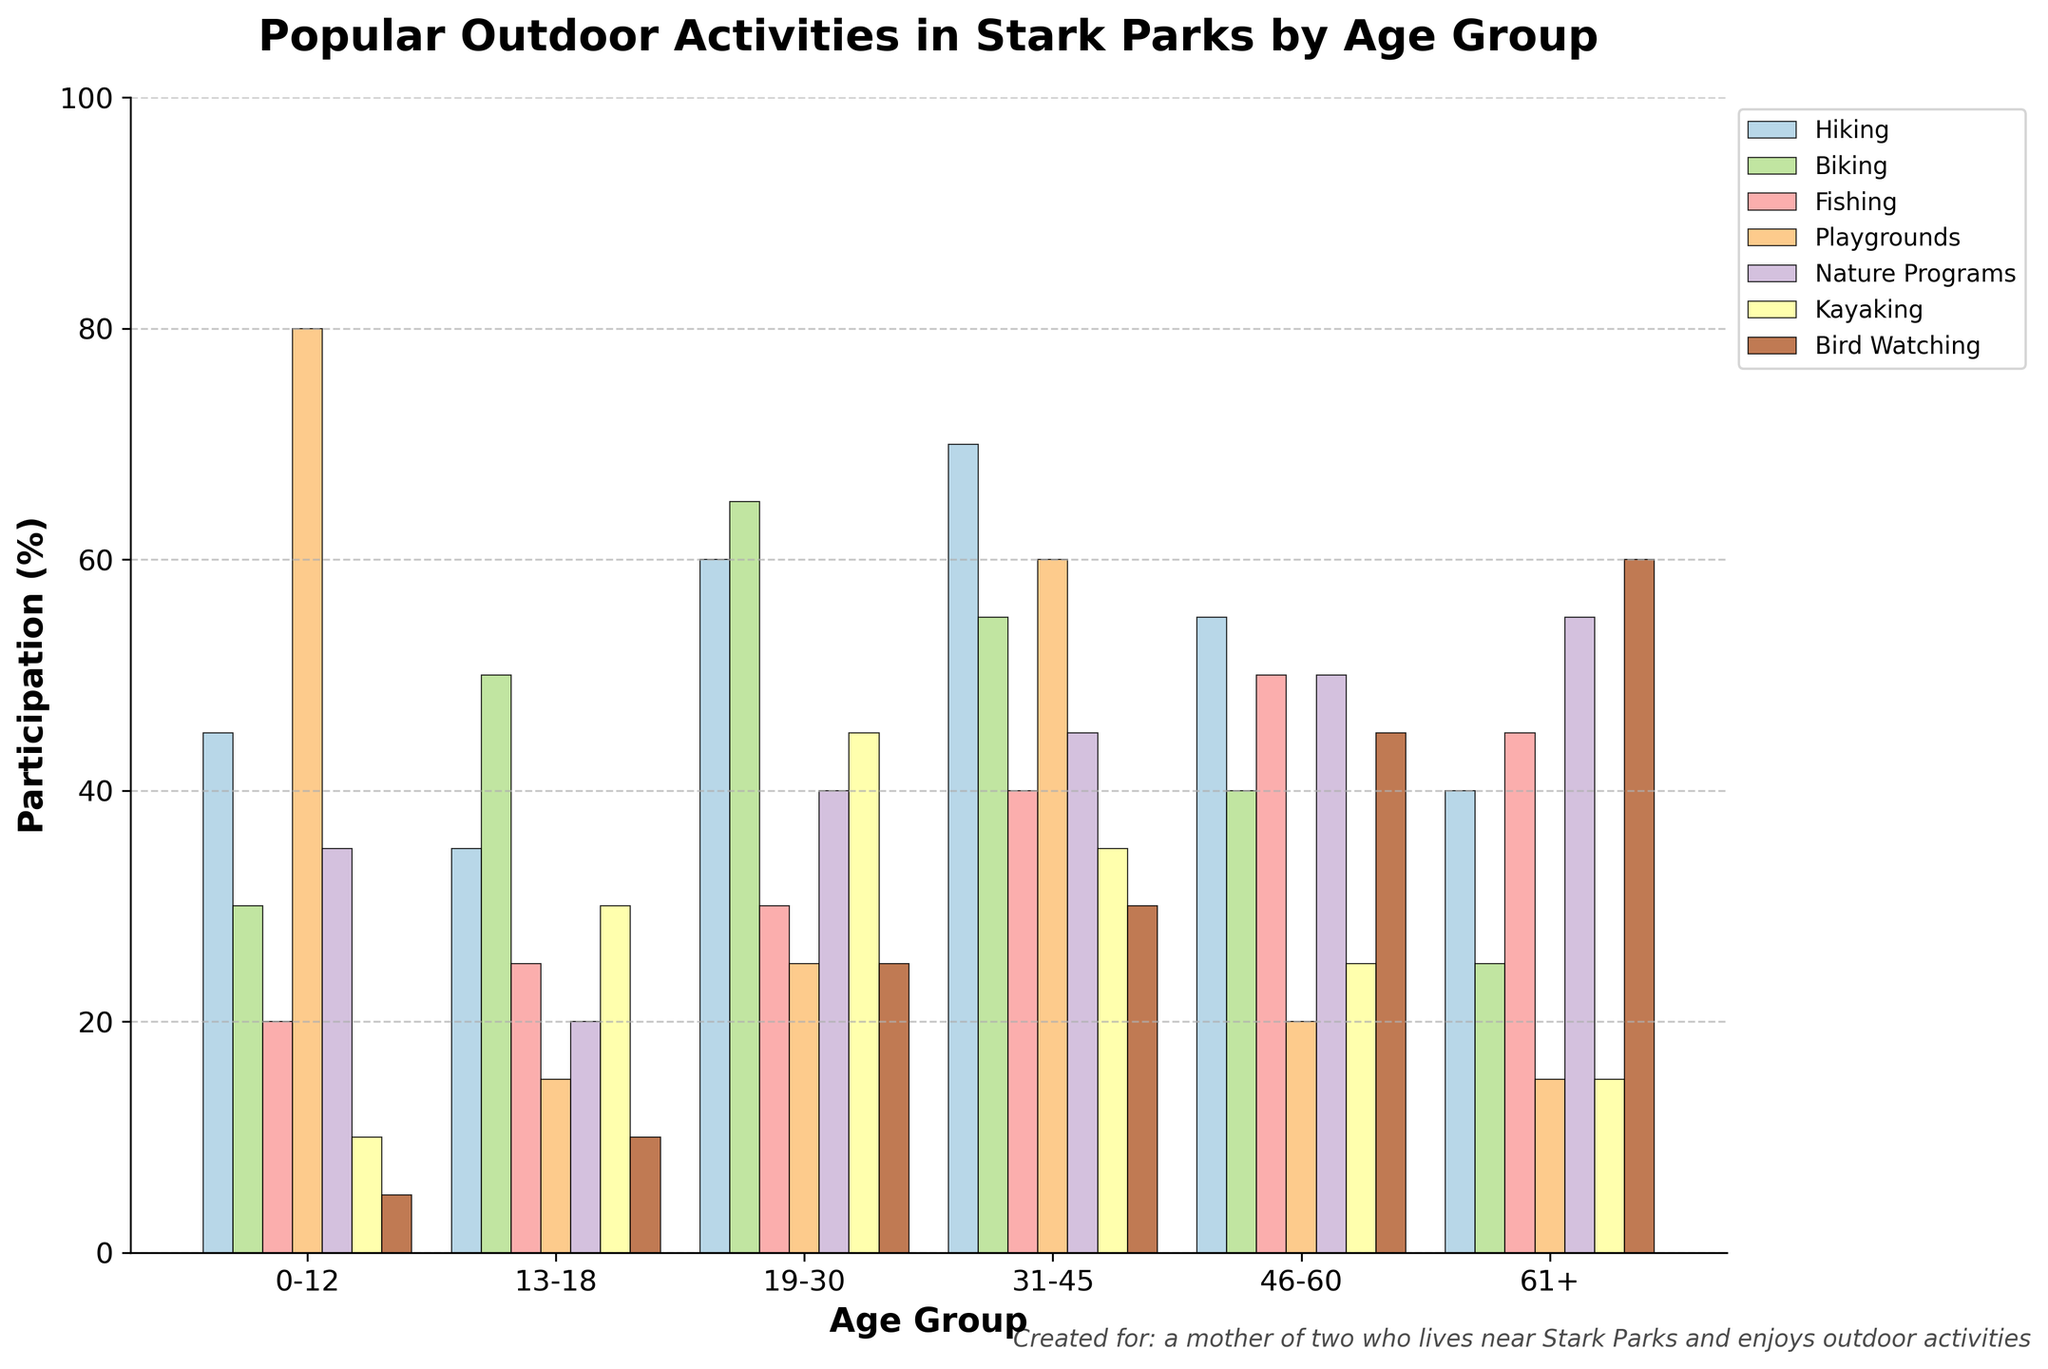What age group has the highest participation in hiking? The age group with the highest participation in hiking has the tallest bar in the hiking category. According to the figure, the age group 31-45 has the highest participation in hiking.
Answer: 31-45 Which activity has the least participation for the 0-12 age group? The activity with the least participation for the 0-12 age group corresponds to the shortest bar within that age group. For the 0-12 age group, bird watching has the lowest participation.
Answer: Bird Watching What is the difference between biking participation for the 13-18 age group and the 61+ age group? To find the difference, look at the heights of the biking bars for the 13-18 and 61+ age groups. Subtract the biking value of the 61+ age group from the value of the 13-18 age group: 50 - 25 = 25.
Answer: 25 Which age group has the largest variety in participation across all activities? To determine the age group with the largest variety, compare the range of participation values (from the highest to the lowest bar) for each age group. The range is highest when there is a significant difference between the maximum and minimum participation percentages. The age group 0-12 has the highest range (80 for playgrounds and 5 for bird watching), showing the largest variety.
Answer: 0-12 What is the sum of participation in nature programs for all age groups? Sum the heights of all the nature programs bars across different age groups: 35 + 20 + 40 + 45 + 50 + 55 = 245.
Answer: 245 Which two age groups have similar participation rates in kayaking? Compare the heights of the kayaking bars for similar values. The age groups 13-18 and 31-45 both have bars at similar heights for kayaking (30 and 35, respectively).
Answer: 13-18 and 31-45 What is the difference in participation in playgrounds between the 0-12 and 31-45 age groups? Subtract the height of the playgrounds bar for the 0-12 group from the 31-45 group: 80 - 60 = 20.
Answer: 20 Which activity has the highest participation for the 46-60 age group? Look for the tallest bar in the 46-60 age group. Fishing has the highest participation in this age group.
Answer: Fishing What is the average participation in bird watching across all age groups? Add up all the participation percentages for bird watching and divide by the number of age groups: (5 + 10 + 25 + 30 + 45 + 60) / 6 = 175 / 6 ≈ 29.17.
Answer: 29.17 Is the participation in fishing higher in the 31-45 age group or the 61+ age group? Compare the heights of the fishing bars for these two age groups. The 31-45 age group participation (40) is lower than the 61+ age group participation (45).
Answer: 61+ 